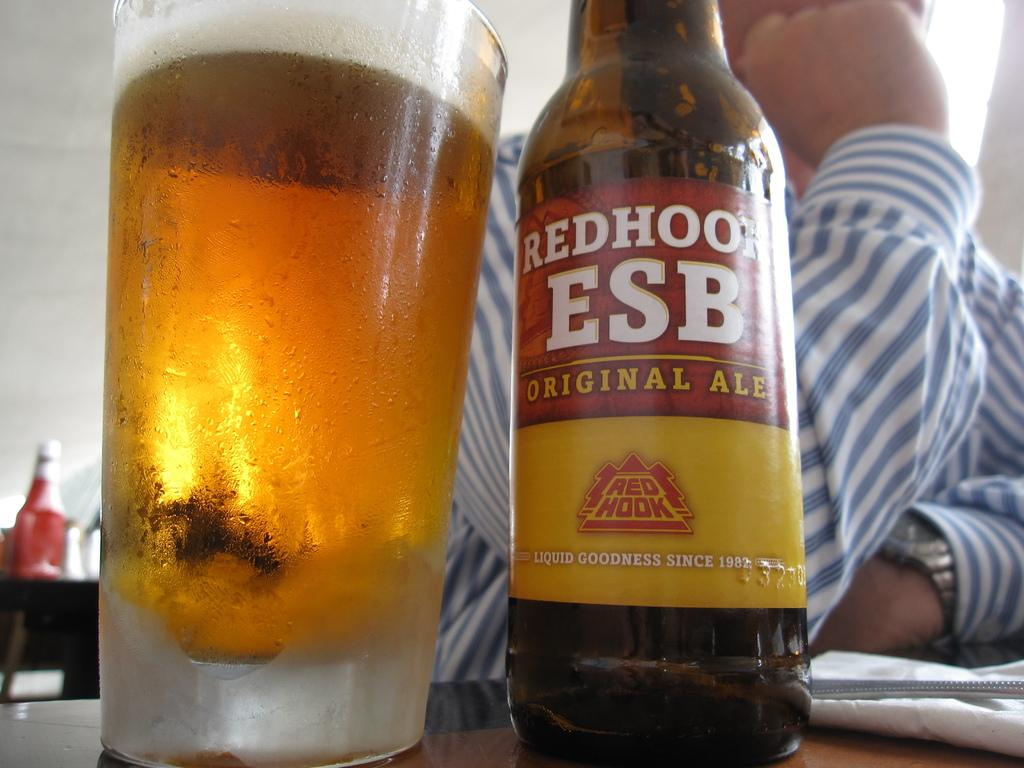Provide a one-sentence caption for the provided image. A bottle of  orginal ale sitting next to a cold glass filled with the ale, a man is sitting behind it. 